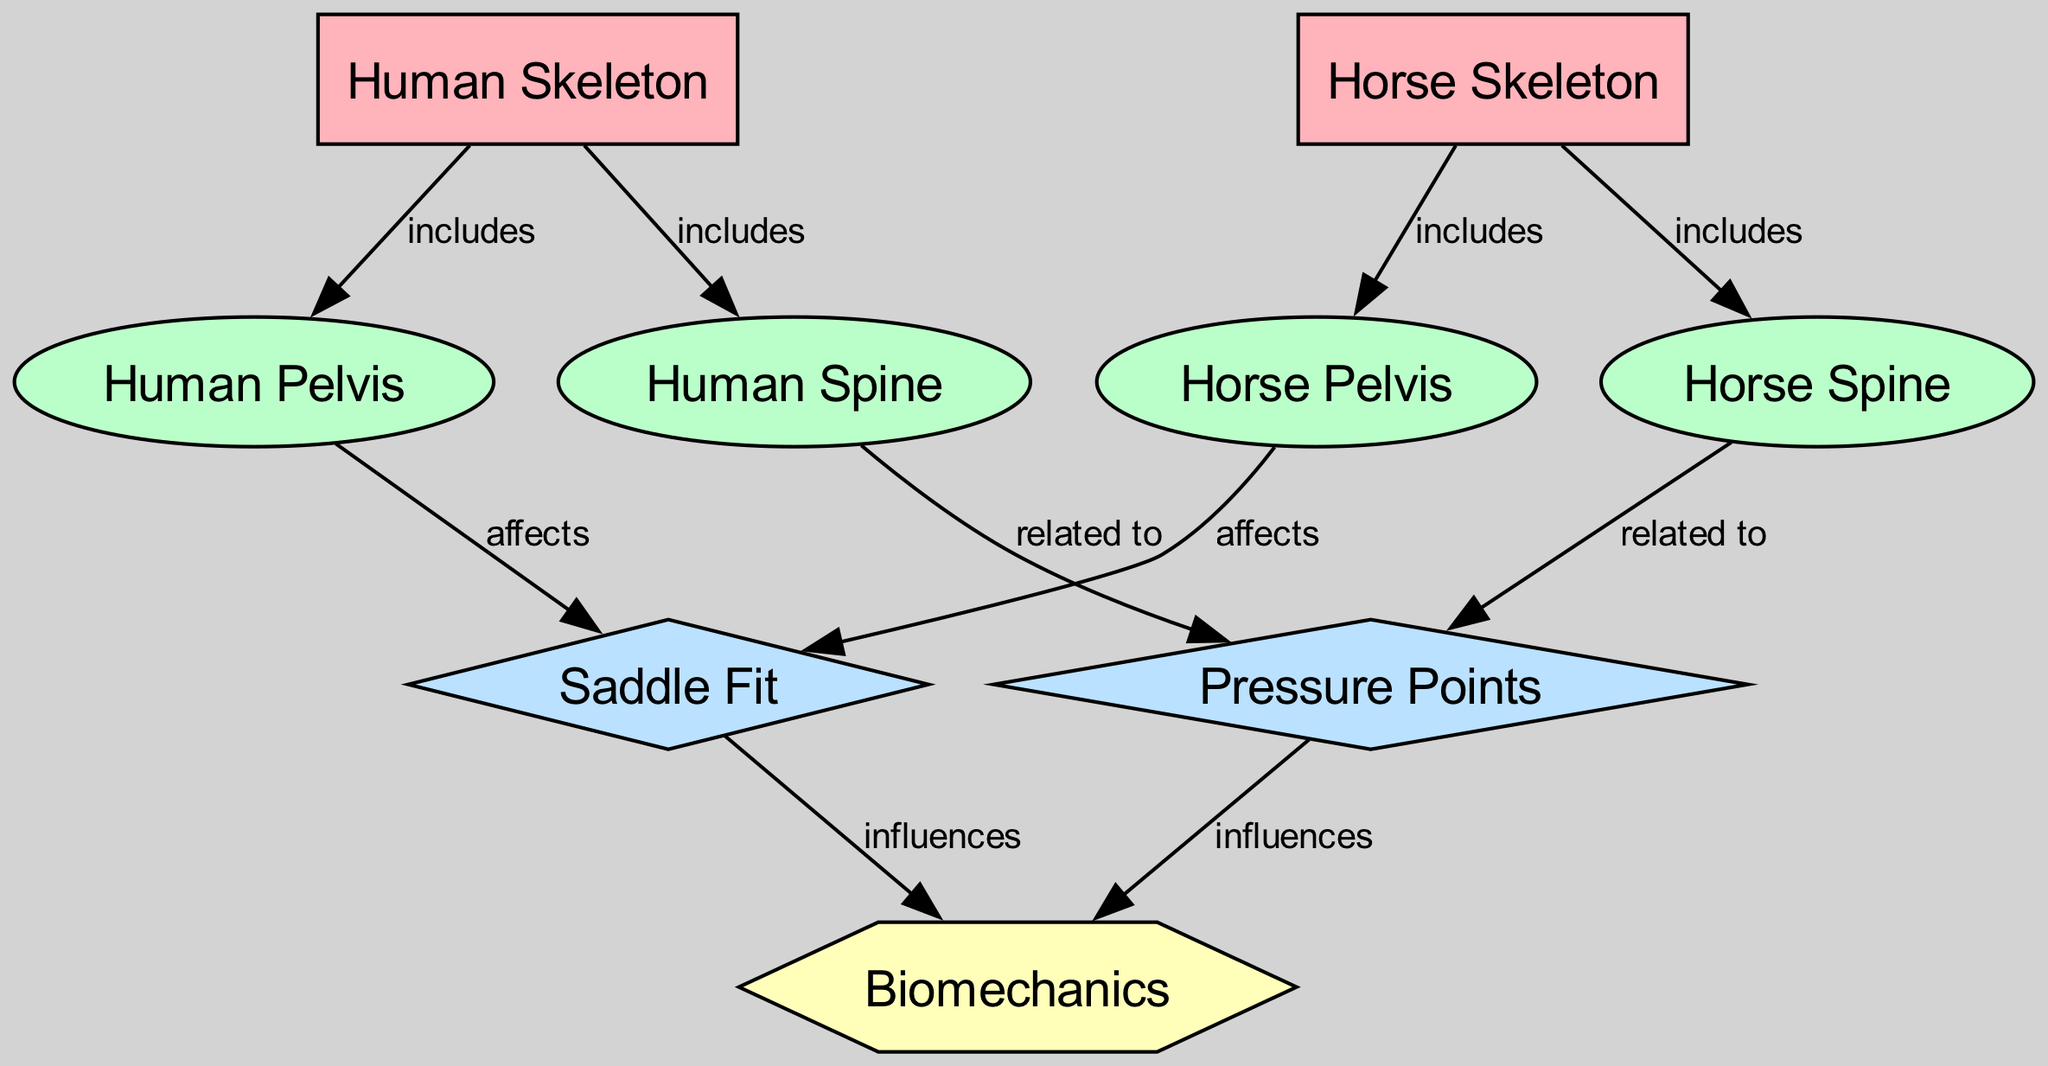What are the two entities represented in the diagram? The diagram includes two major entities: the human skeleton and the horse skeleton. By examining the nodes labeled as "Human Skeleton" and "Horse Skeleton," we can identify them clearly.
Answer: Human Skeleton, Horse Skeleton How many nodes are present in the diagram? The diagram features a total of 10 nodes, which can be counted from the node list provided. These include the two entities and several anatomical, design, and conceptual nodes.
Answer: 10 What relationship does the human pelvis have with saddle fit? The human pelvis "affects" saddle fit according to the edge that connects "Human Pelvis" to "Saddle Fit." This means that the structure of the human pelvis has a direct impact on how well a saddle fits.
Answer: Affects What does the horse spine influence in the diagram? The horse spine has a relationship labeled "related to" with pressure points, indicating that the configuration of the horse spine plays a role in determining where pressure points occur when saddle fitting.
Answer: Pressure Points How is the saddle fit related to biomechanics? The diagram indicates that saddle fit "influences" biomechanics. This suggests that how well a saddle fits on the horse or rider can affect the movement and body mechanics involved in riding.
Answer: Influences How many edges are there in the diagram? The diagram consists of 9 edges, which can be counted by examining the connections shown between the various nodes. Each relationship between nodes is represented by an edge.
Answer: 9 What effect does the horse pelvis have on saddle fit? Similar to the human pelvis, the horse pelvis also "affects" saddle fit, which is shown by the direct connection in the diagram. This means the structure of the horse's pelvis impacts saddle compatibility.
Answer: Affects What concept is influenced by both saddle fit and pressure points? Both saddle fit and pressure points influence the concept of biomechanics according to the edges that connect them in the diagram. This indicates that both elements play a role in understanding the mechanics involved in riding.
Answer: Biomechanics 